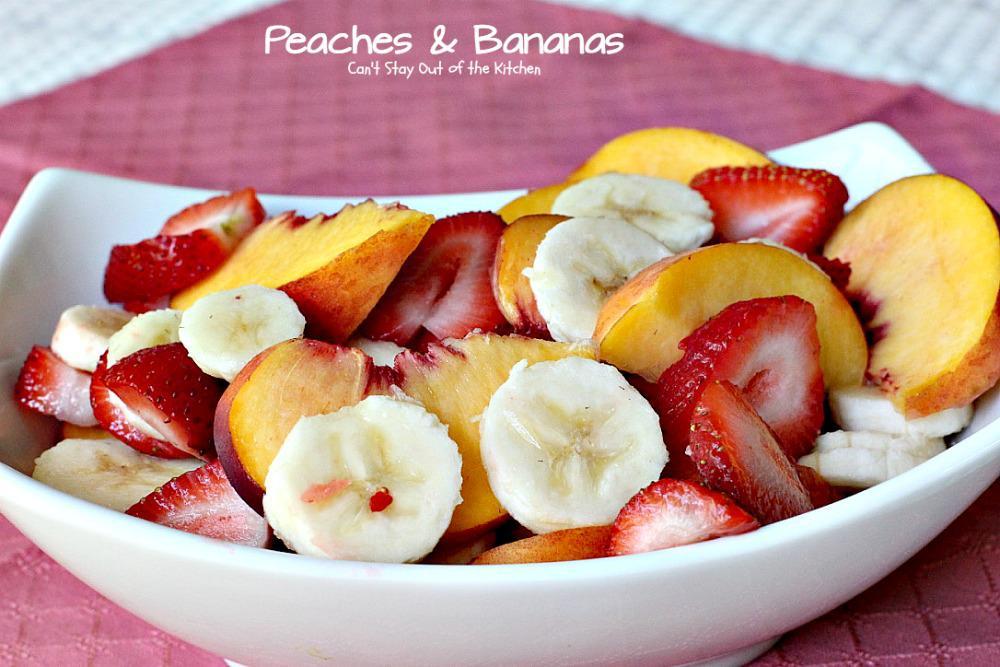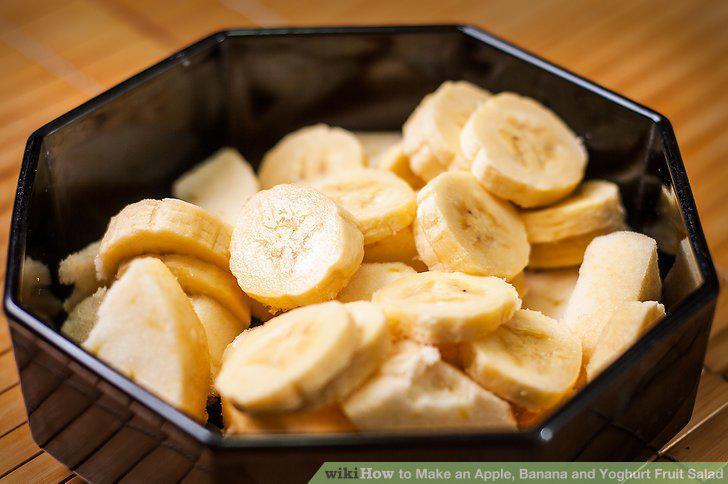The first image is the image on the left, the second image is the image on the right. Given the left and right images, does the statement "The left image shows mixed fruit pieces in a white bowl, and the right image shows sliced bananas in an octagon-shaped black bowl." hold true? Answer yes or no. Yes. The first image is the image on the left, the second image is the image on the right. Evaluate the accuracy of this statement regarding the images: "there is a white bowl with strawberries bananas and other varying fruits". Is it true? Answer yes or no. Yes. 